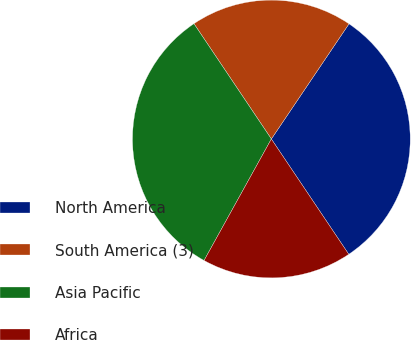Convert chart. <chart><loc_0><loc_0><loc_500><loc_500><pie_chart><fcel>North America<fcel>South America (3)<fcel>Asia Pacific<fcel>Africa<nl><fcel>31.15%<fcel>18.85%<fcel>32.54%<fcel>17.46%<nl></chart> 